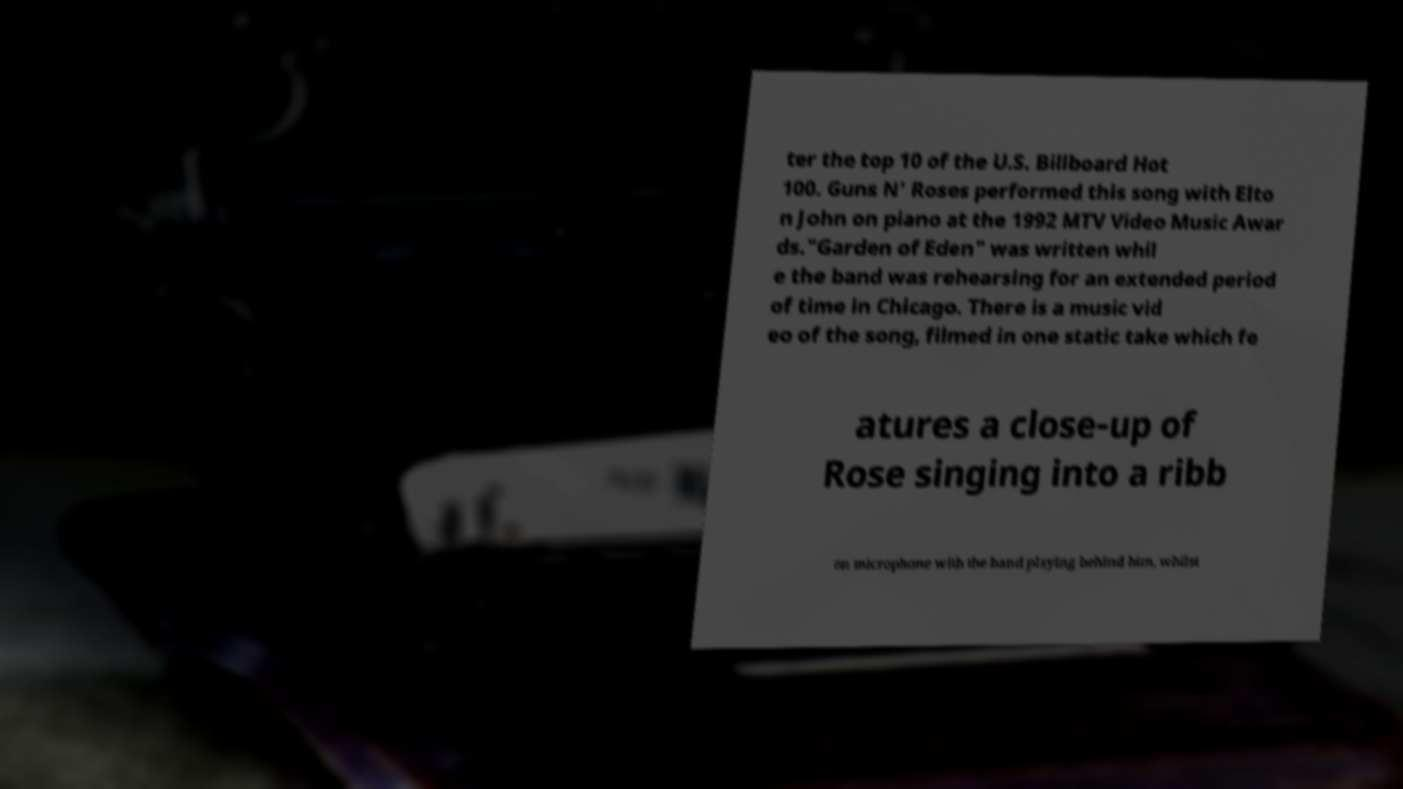Please read and relay the text visible in this image. What does it say? ter the top 10 of the U.S. Billboard Hot 100. Guns N' Roses performed this song with Elto n John on piano at the 1992 MTV Video Music Awar ds."Garden of Eden" was written whil e the band was rehearsing for an extended period of time in Chicago. There is a music vid eo of the song, filmed in one static take which fe atures a close-up of Rose singing into a ribb on microphone with the band playing behind him, whilst 